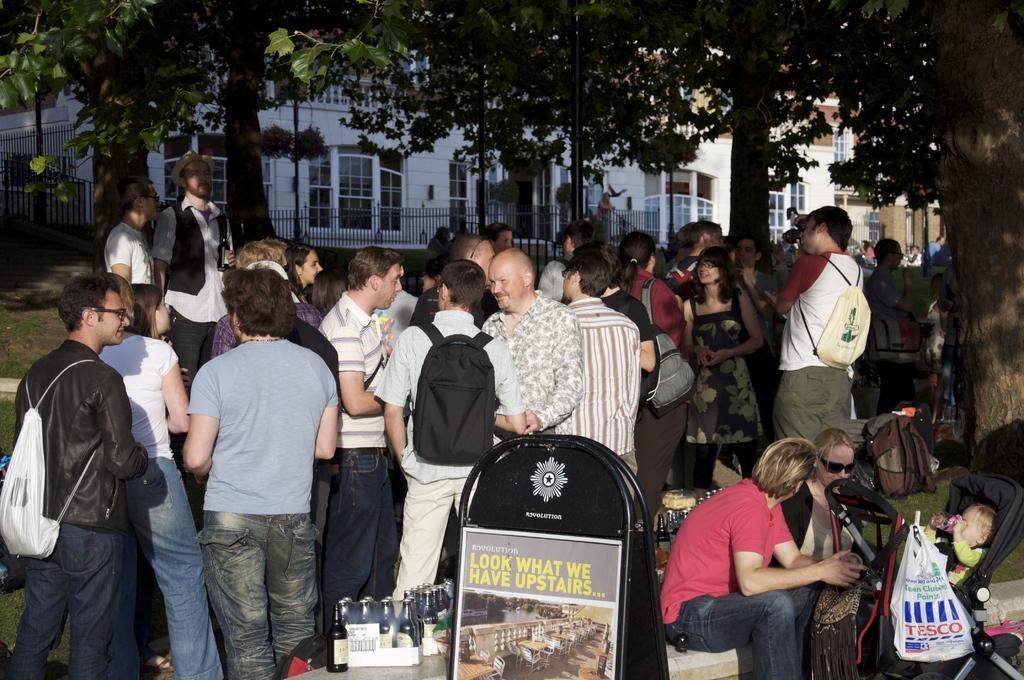Can you describe this image briefly? In this image we can see a group of people standing on the ground. We can also see some bottles on the surface, a board with some text and pictures on it, a bag and some grass. On the right side we can see a man and a woman sitting beside a trolley with a baby inside it and a cover hanged to it. On the backside we can see a building with windows, a fence, the bark of the trees and a group of trees. 